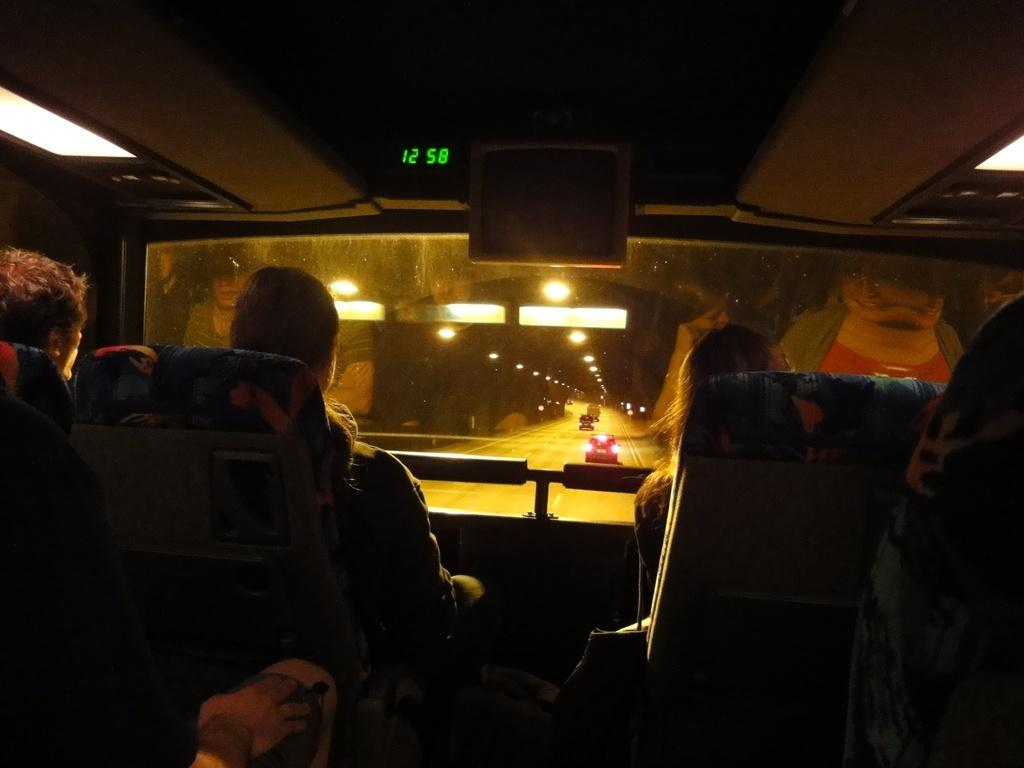What is the main subject of the image? There is a vehicle in the image. Who or what is inside the vehicle? There are people sitting in the vehicle. What can be seen in the background of the image? There are lights visible in the background. Are there any other vehicles in the image? Yes, there are other vehicles in the image. What type of pen is being used to write on the grass in the image? There is no pen or grass present in the image. What is being stored in the crate in the image? There is no crate present in the image. 